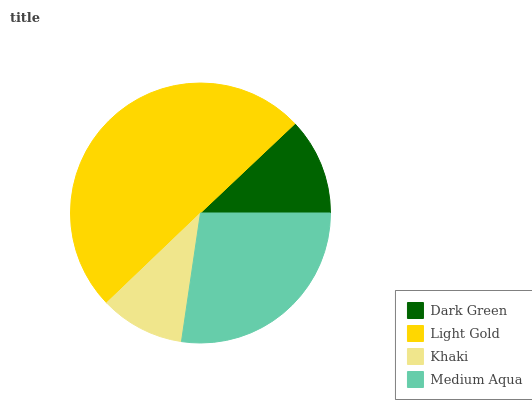Is Khaki the minimum?
Answer yes or no. Yes. Is Light Gold the maximum?
Answer yes or no. Yes. Is Light Gold the minimum?
Answer yes or no. No. Is Khaki the maximum?
Answer yes or no. No. Is Light Gold greater than Khaki?
Answer yes or no. Yes. Is Khaki less than Light Gold?
Answer yes or no. Yes. Is Khaki greater than Light Gold?
Answer yes or no. No. Is Light Gold less than Khaki?
Answer yes or no. No. Is Medium Aqua the high median?
Answer yes or no. Yes. Is Dark Green the low median?
Answer yes or no. Yes. Is Light Gold the high median?
Answer yes or no. No. Is Khaki the low median?
Answer yes or no. No. 